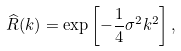Convert formula to latex. <formula><loc_0><loc_0><loc_500><loc_500>\widehat { R } ( k ) = \exp \left [ - \frac { 1 } { 4 } \sigma ^ { 2 } k ^ { 2 } \right ] ,</formula> 